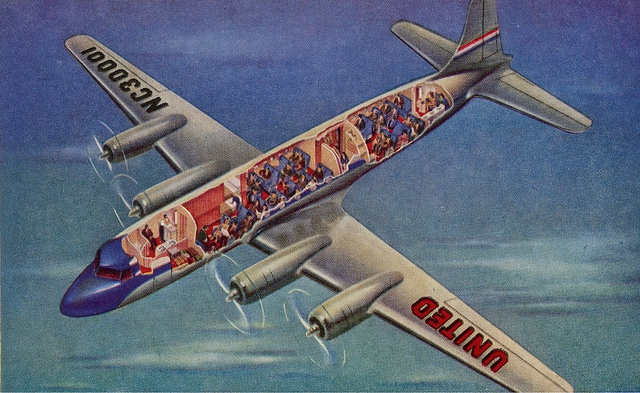Describe the objects in this image and their specific colors. I can see airplane in gray, darkgray, black, and tan tones, people in gray, maroon, brown, and black tones, people in gray, maroon, black, brown, and purple tones, people in gray, maroon, and black tones, and people in gray, black, purple, brown, and maroon tones in this image. 